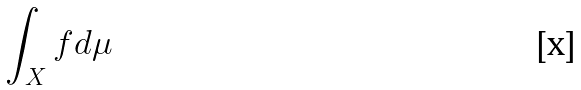<formula> <loc_0><loc_0><loc_500><loc_500>\int _ { X } f d \mu</formula> 